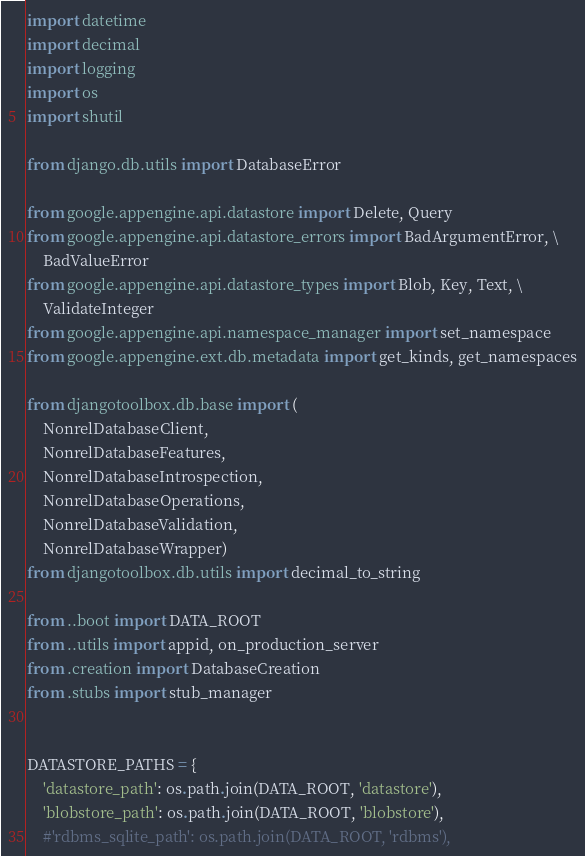Convert code to text. <code><loc_0><loc_0><loc_500><loc_500><_Python_>import datetime
import decimal
import logging
import os
import shutil

from django.db.utils import DatabaseError

from google.appengine.api.datastore import Delete, Query
from google.appengine.api.datastore_errors import BadArgumentError, \
    BadValueError
from google.appengine.api.datastore_types import Blob, Key, Text, \
    ValidateInteger
from google.appengine.api.namespace_manager import set_namespace
from google.appengine.ext.db.metadata import get_kinds, get_namespaces

from djangotoolbox.db.base import (
    NonrelDatabaseClient,
    NonrelDatabaseFeatures,
    NonrelDatabaseIntrospection,
    NonrelDatabaseOperations,
    NonrelDatabaseValidation,
    NonrelDatabaseWrapper)
from djangotoolbox.db.utils import decimal_to_string

from ..boot import DATA_ROOT
from ..utils import appid, on_production_server
from .creation import DatabaseCreation
from .stubs import stub_manager


DATASTORE_PATHS = {
    'datastore_path': os.path.join(DATA_ROOT, 'datastore'),
    'blobstore_path': os.path.join(DATA_ROOT, 'blobstore'),
    #'rdbms_sqlite_path': os.path.join(DATA_ROOT, 'rdbms'),</code> 